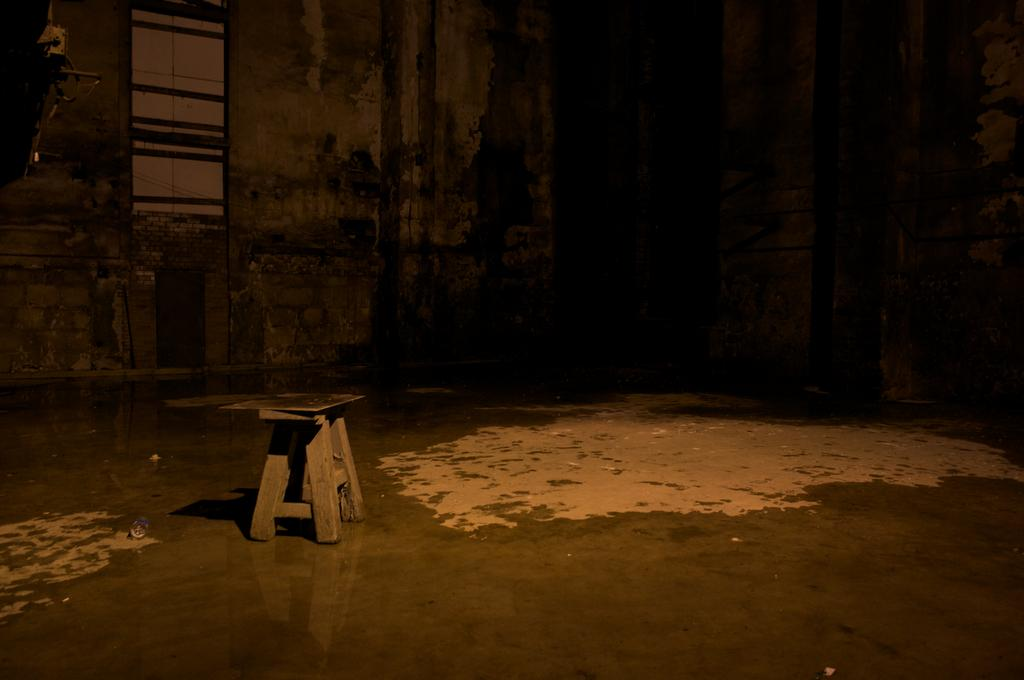What object is located in the center of the image? There is a stool in the center of the image. What can be seen in the background of the image? There is a wall and a window in the background of the image. What is visible at the bottom of the image? There is a floor visible at the bottom of the image. Can you see any crooks or boats in the image? No, there are no crooks or boats present in the image. 